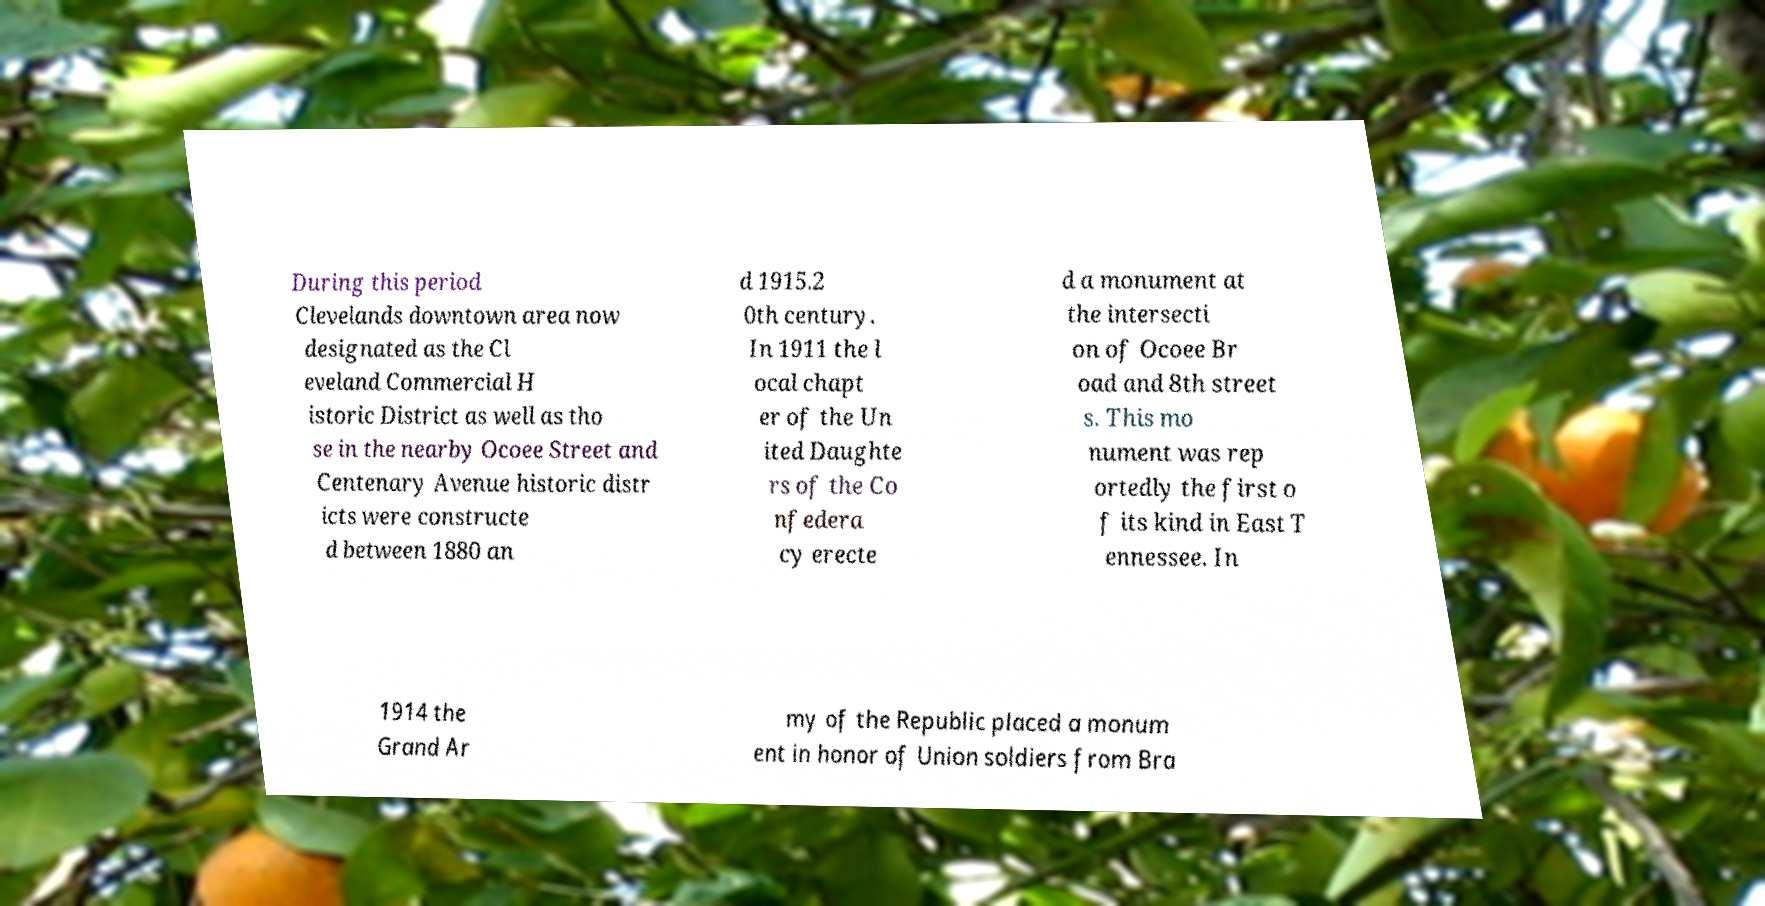Can you read and provide the text displayed in the image?This photo seems to have some interesting text. Can you extract and type it out for me? During this period Clevelands downtown area now designated as the Cl eveland Commercial H istoric District as well as tho se in the nearby Ocoee Street and Centenary Avenue historic distr icts were constructe d between 1880 an d 1915.2 0th century. In 1911 the l ocal chapt er of the Un ited Daughte rs of the Co nfedera cy erecte d a monument at the intersecti on of Ocoee Br oad and 8th street s. This mo nument was rep ortedly the first o f its kind in East T ennessee. In 1914 the Grand Ar my of the Republic placed a monum ent in honor of Union soldiers from Bra 